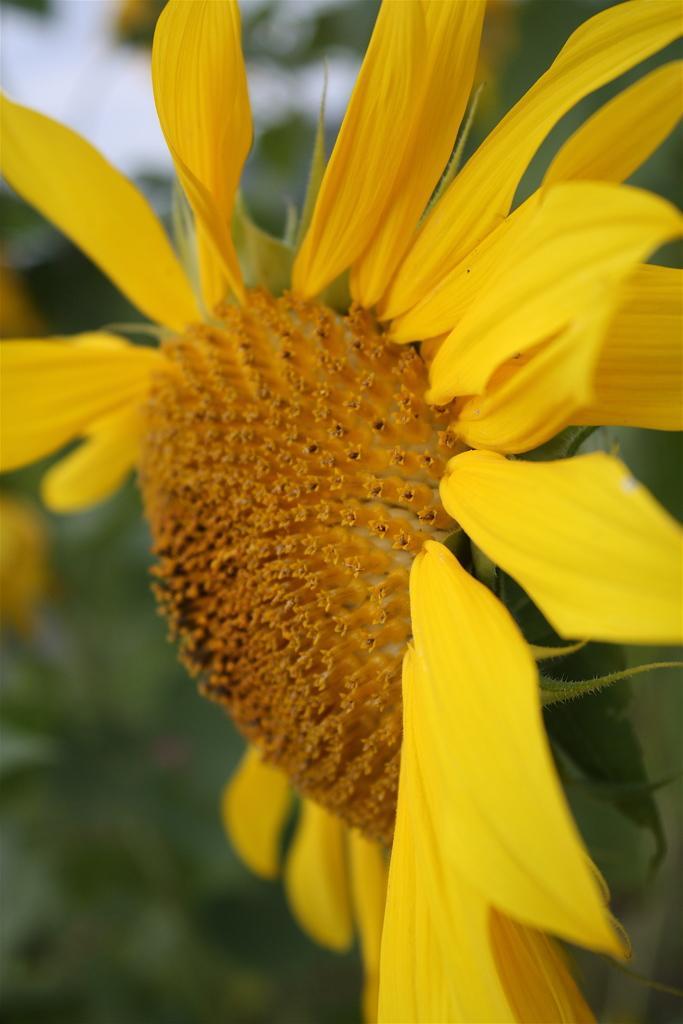Describe this image in one or two sentences. In this image I can see the flower to the plant. The flower is in yellow color and there is a blurred background. 